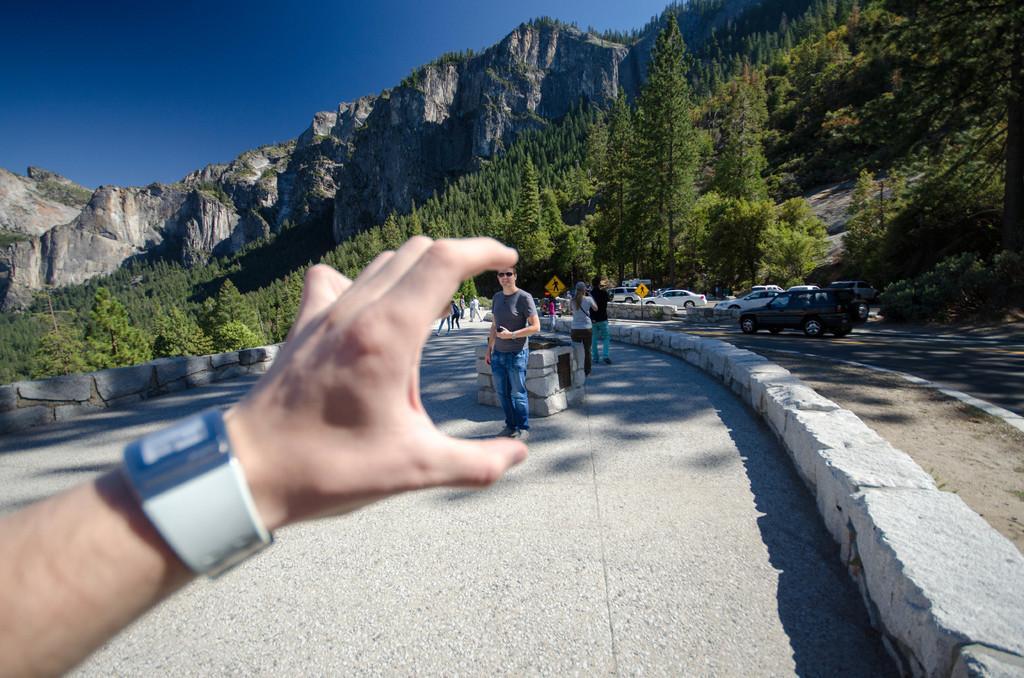Can you describe this image briefly? In this image in the foreground there is a hand with a watch. In the background there are many people, cars on the road. In the back there are hills, trees. The sky is clear. 